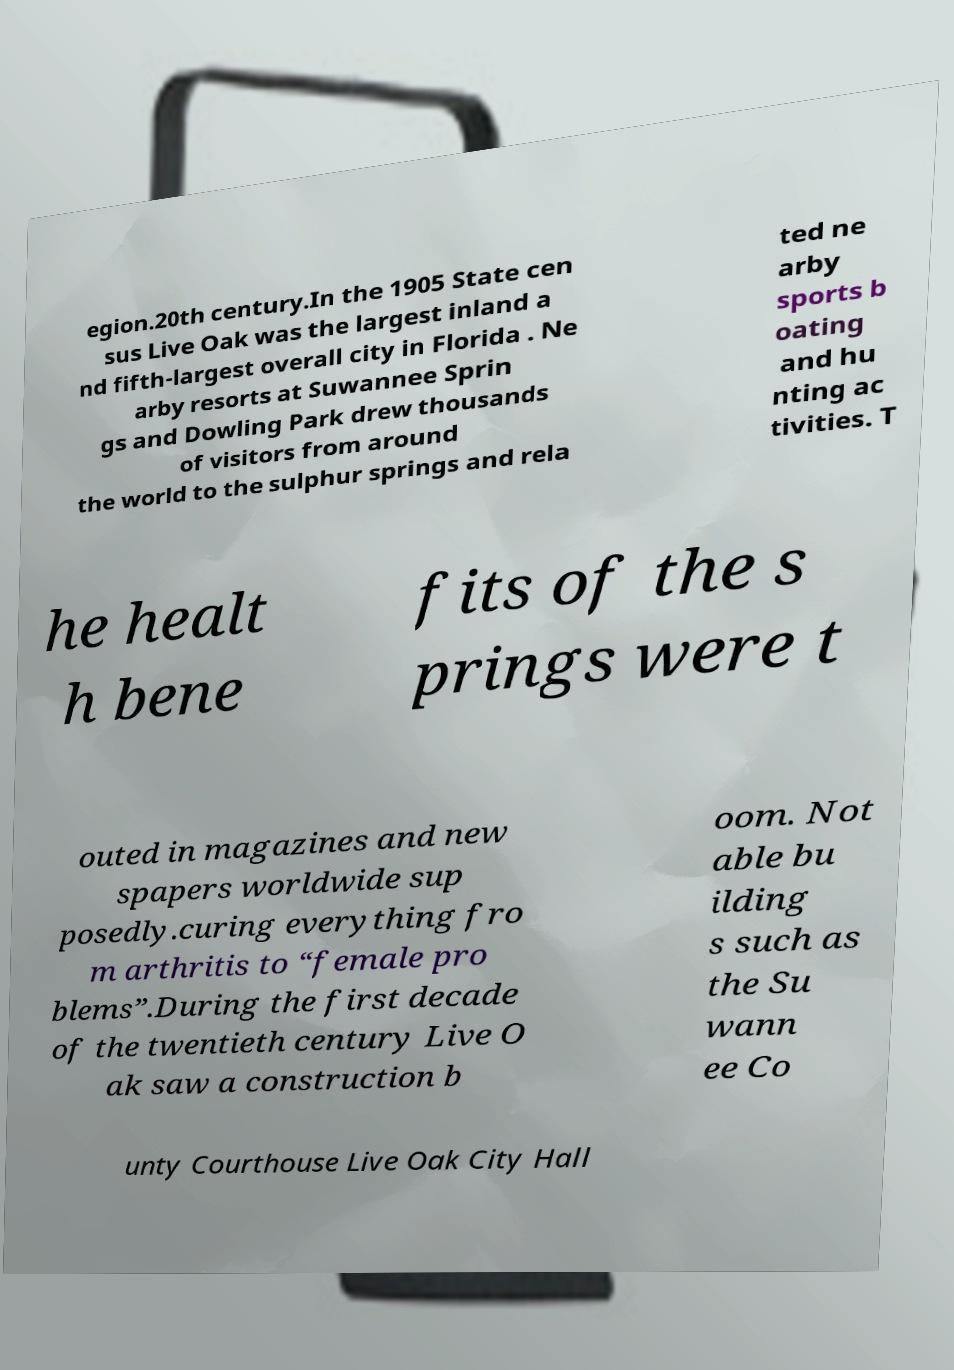What messages or text are displayed in this image? I need them in a readable, typed format. egion.20th century.In the 1905 State cen sus Live Oak was the largest inland a nd fifth-largest overall city in Florida . Ne arby resorts at Suwannee Sprin gs and Dowling Park drew thousands of visitors from around the world to the sulphur springs and rela ted ne arby sports b oating and hu nting ac tivities. T he healt h bene fits of the s prings were t outed in magazines and new spapers worldwide sup posedly.curing everything fro m arthritis to “female pro blems”.During the first decade of the twentieth century Live O ak saw a construction b oom. Not able bu ilding s such as the Su wann ee Co unty Courthouse Live Oak City Hall 